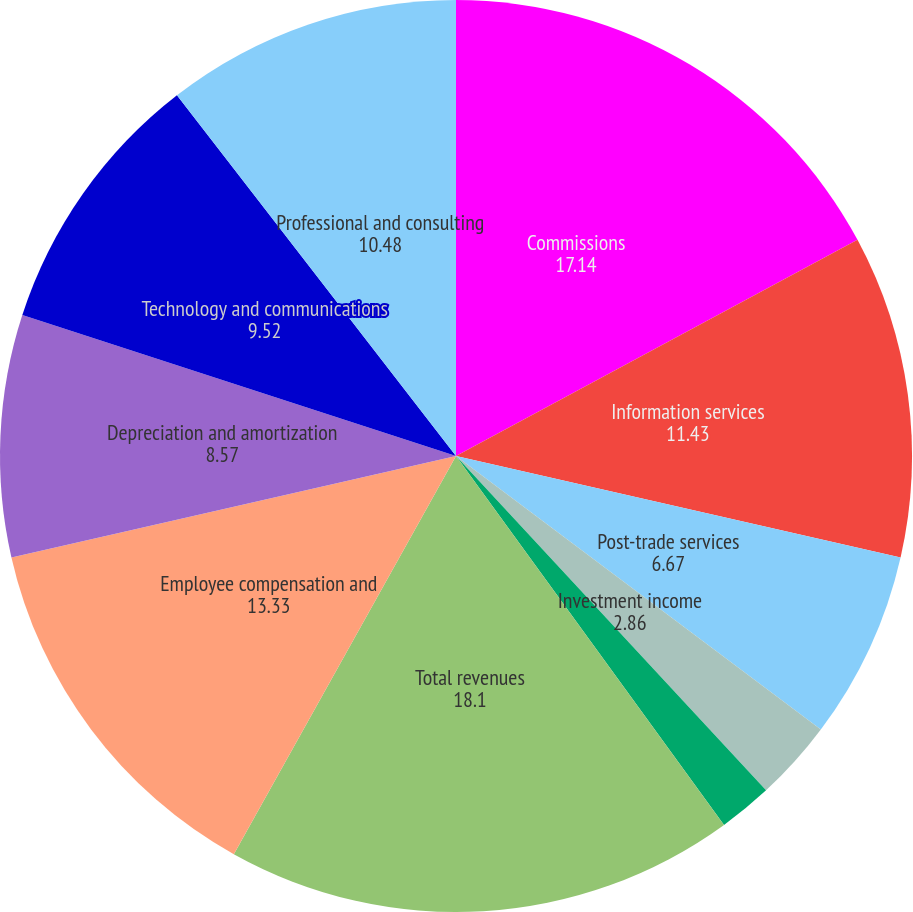Convert chart to OTSL. <chart><loc_0><loc_0><loc_500><loc_500><pie_chart><fcel>Commissions<fcel>Information services<fcel>Post-trade services<fcel>Investment income<fcel>Other<fcel>Total revenues<fcel>Employee compensation and<fcel>Depreciation and amortization<fcel>Technology and communications<fcel>Professional and consulting<nl><fcel>17.14%<fcel>11.43%<fcel>6.67%<fcel>2.86%<fcel>1.9%<fcel>18.1%<fcel>13.33%<fcel>8.57%<fcel>9.52%<fcel>10.48%<nl></chart> 